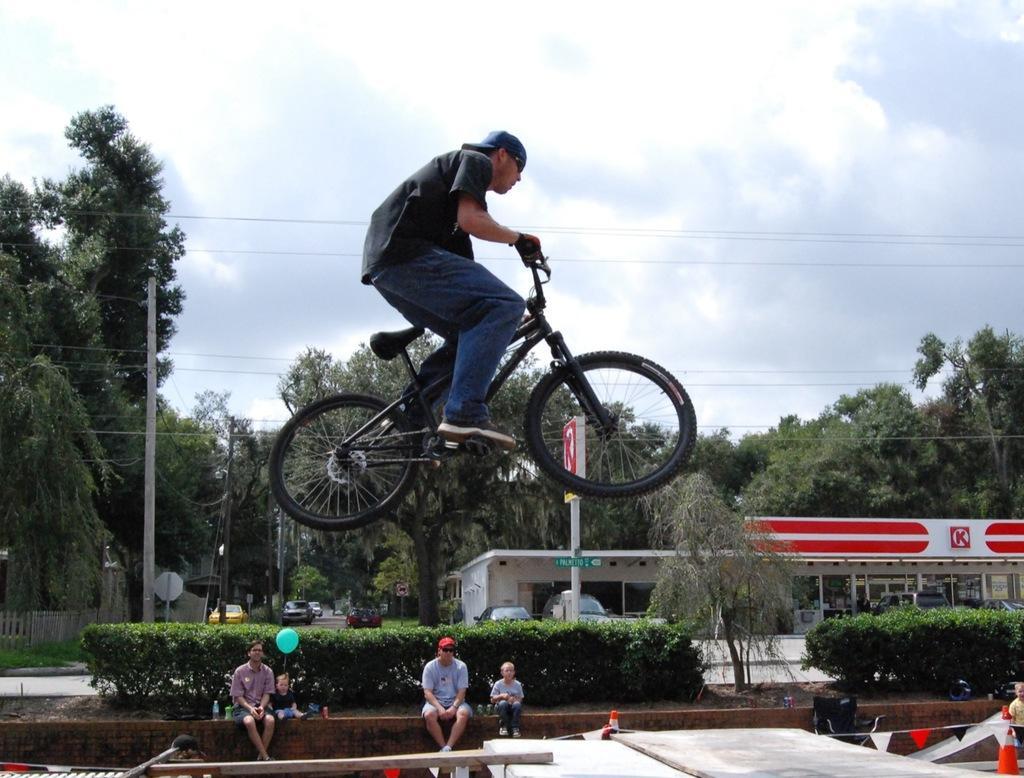Could you give a brief overview of what you see in this image? In the middle I can see a person is doing a stunt on the bicycle. At the bottom I can see five persons are sitting on a fence, trees, poles, houses and vehicles on the road. On the top I can see the sky and wires. This image is taken during a sunny day. 